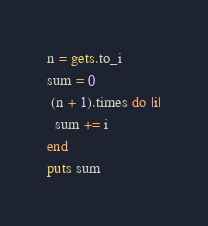Convert code to text. <code><loc_0><loc_0><loc_500><loc_500><_Ruby_>n = gets.to_i
sum = 0
 (n + 1).times do |i|
  sum += i
end
puts sum
</code> 